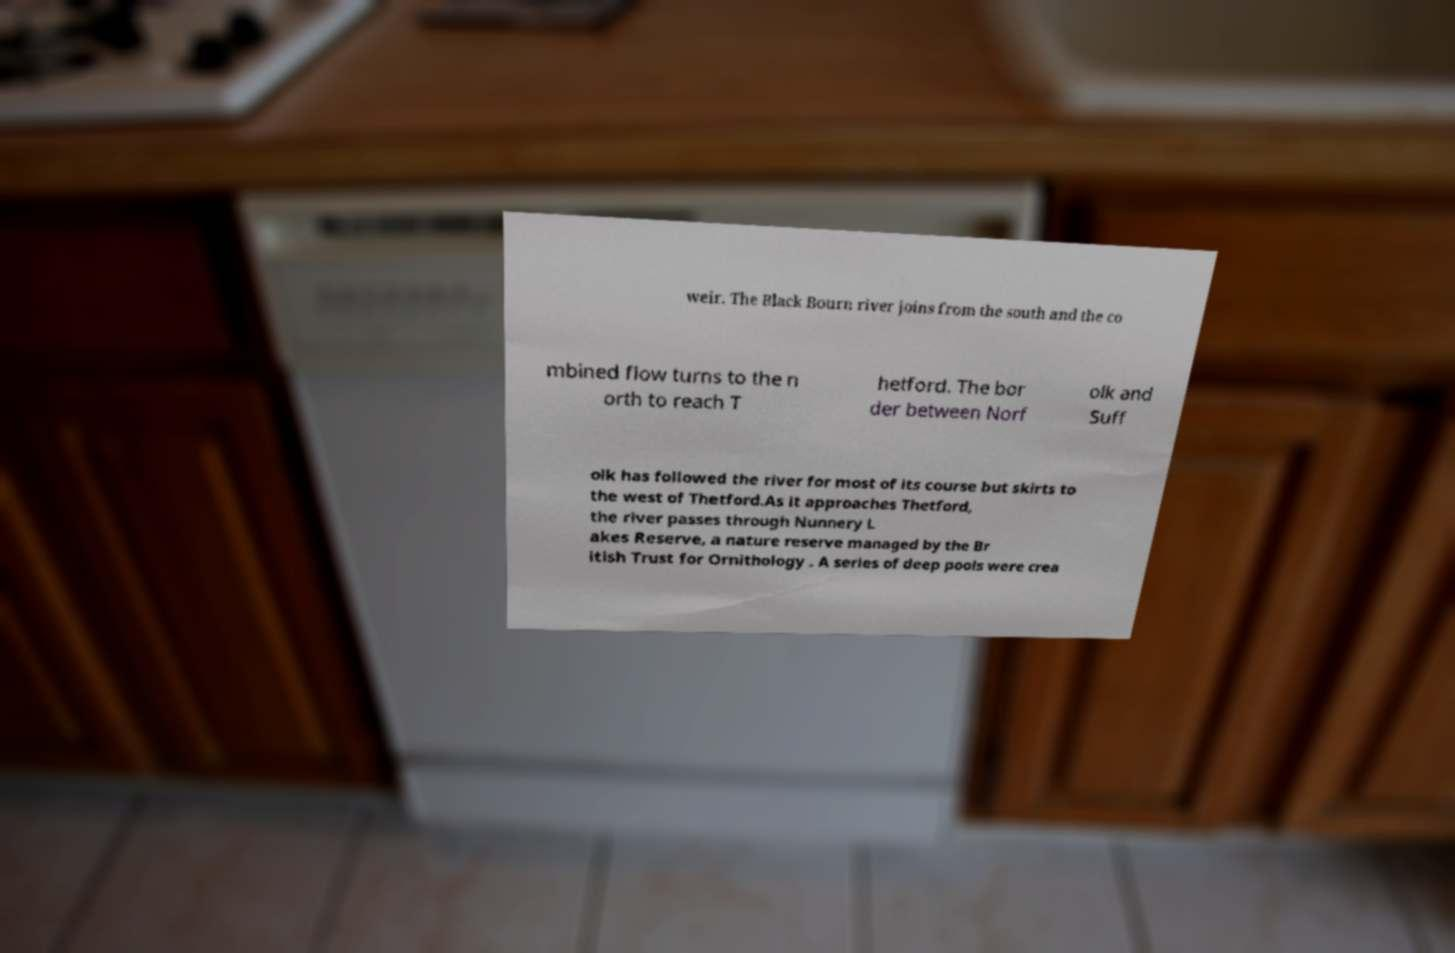What messages or text are displayed in this image? I need them in a readable, typed format. weir. The Black Bourn river joins from the south and the co mbined flow turns to the n orth to reach T hetford. The bor der between Norf olk and Suff olk has followed the river for most of its course but skirts to the west of Thetford.As it approaches Thetford, the river passes through Nunnery L akes Reserve, a nature reserve managed by the Br itish Trust for Ornithology . A series of deep pools were crea 